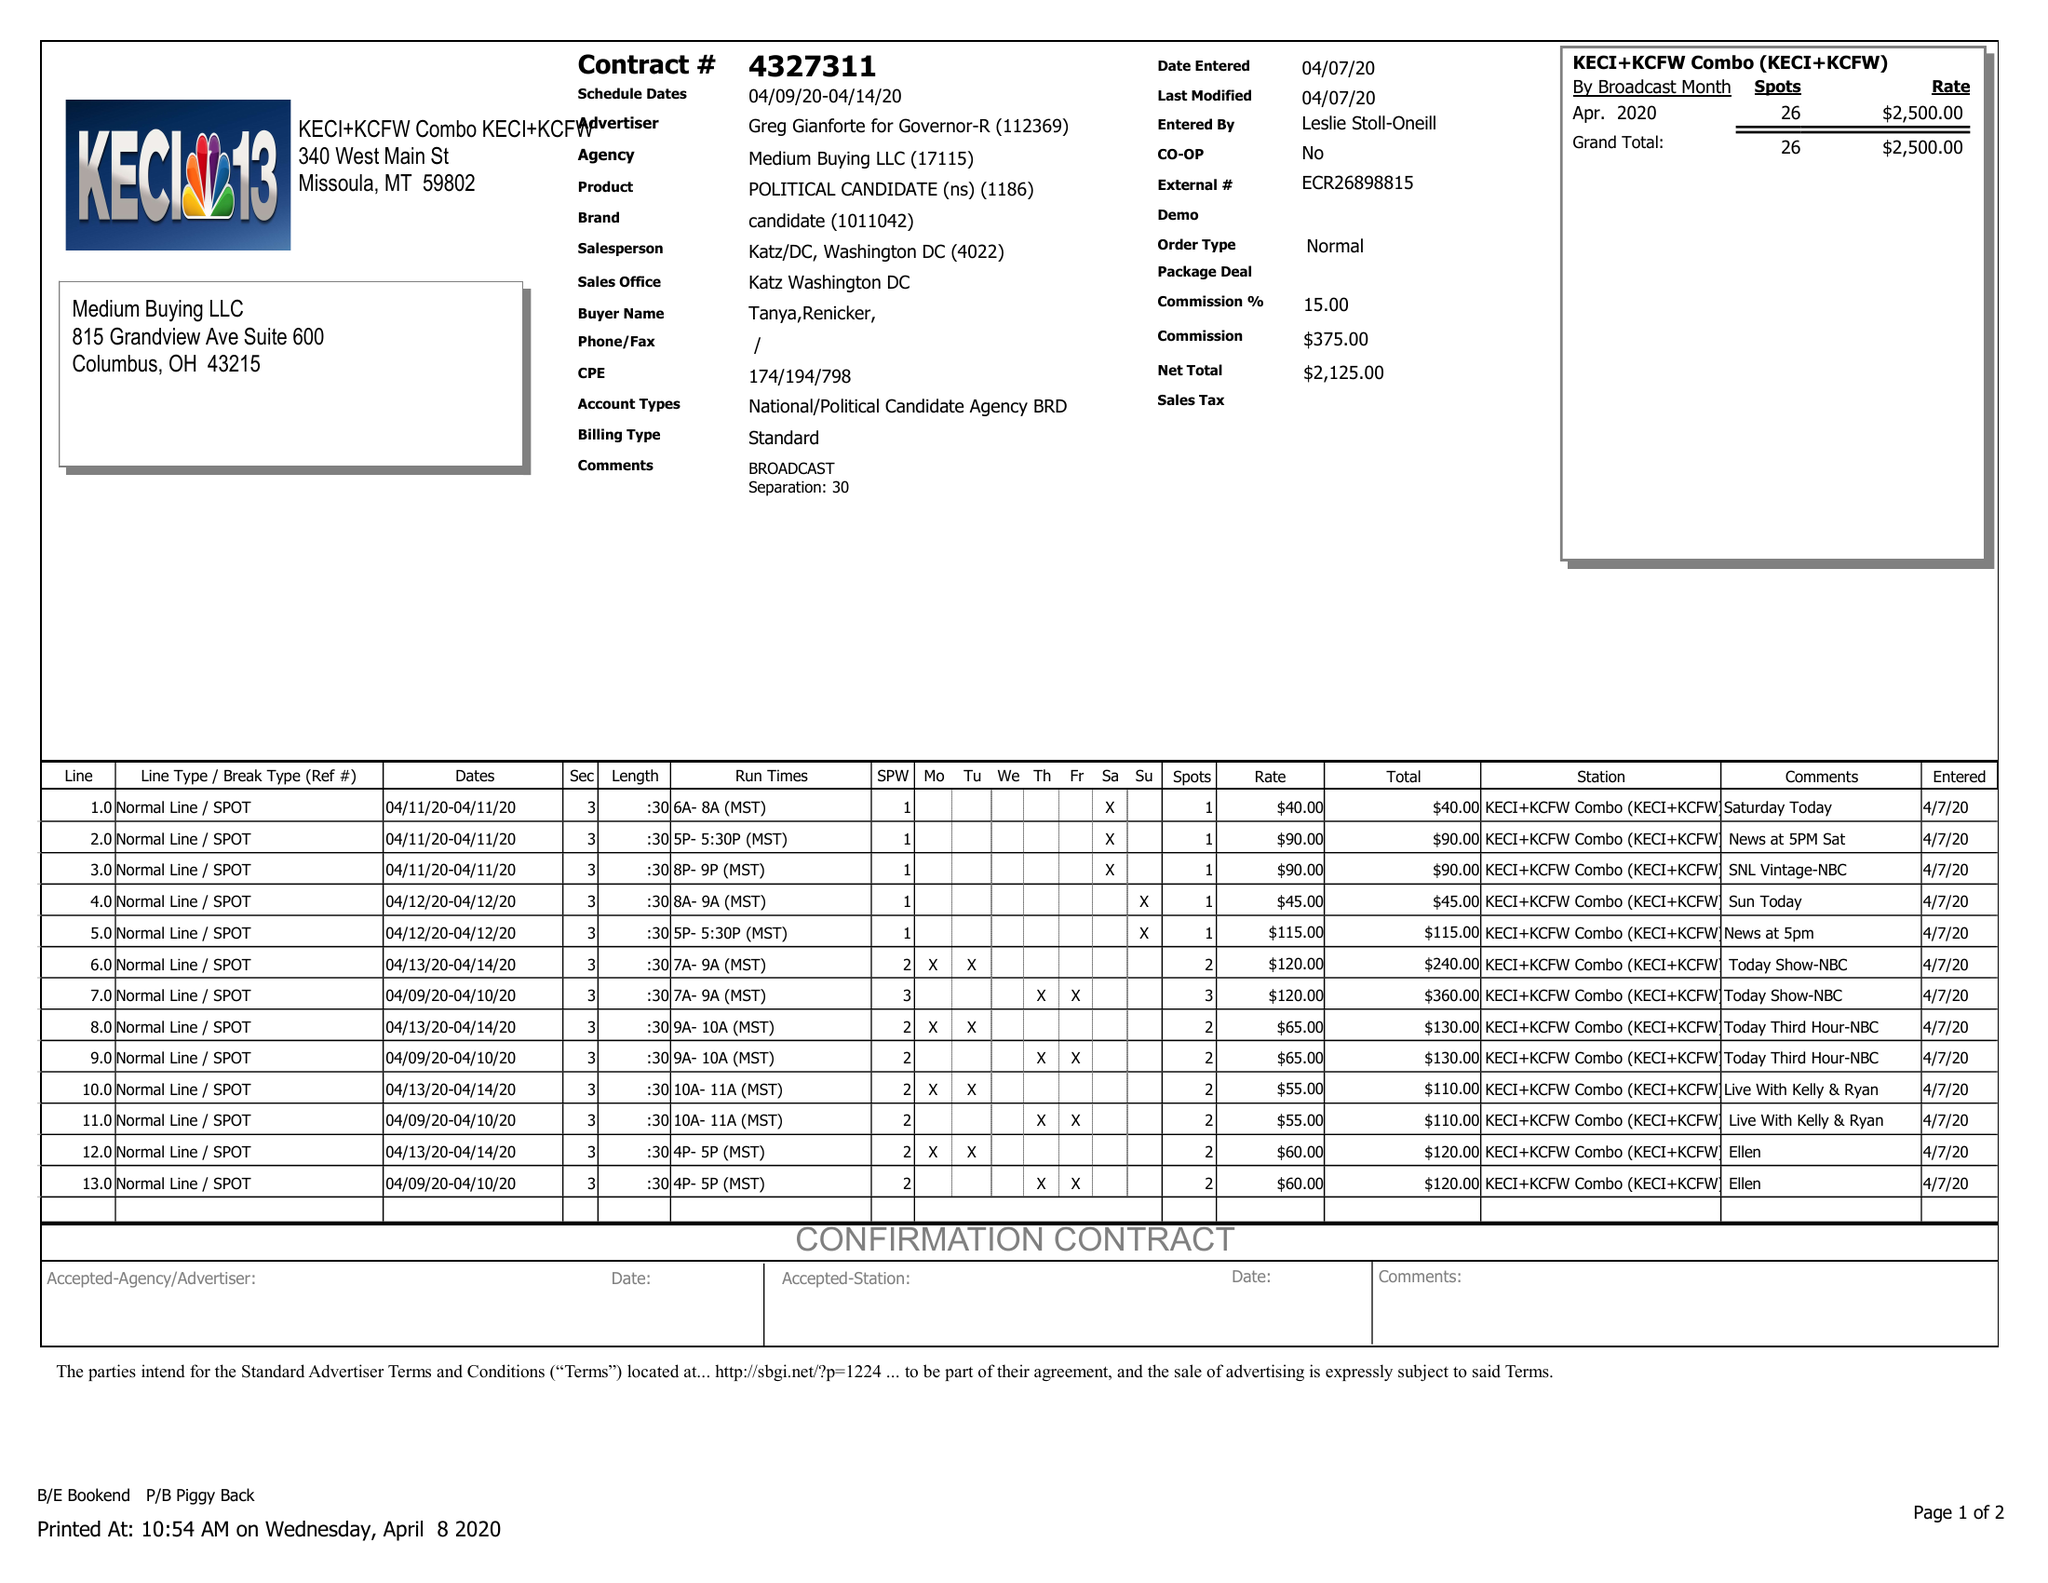What is the value for the flight_from?
Answer the question using a single word or phrase. 04/09/20 